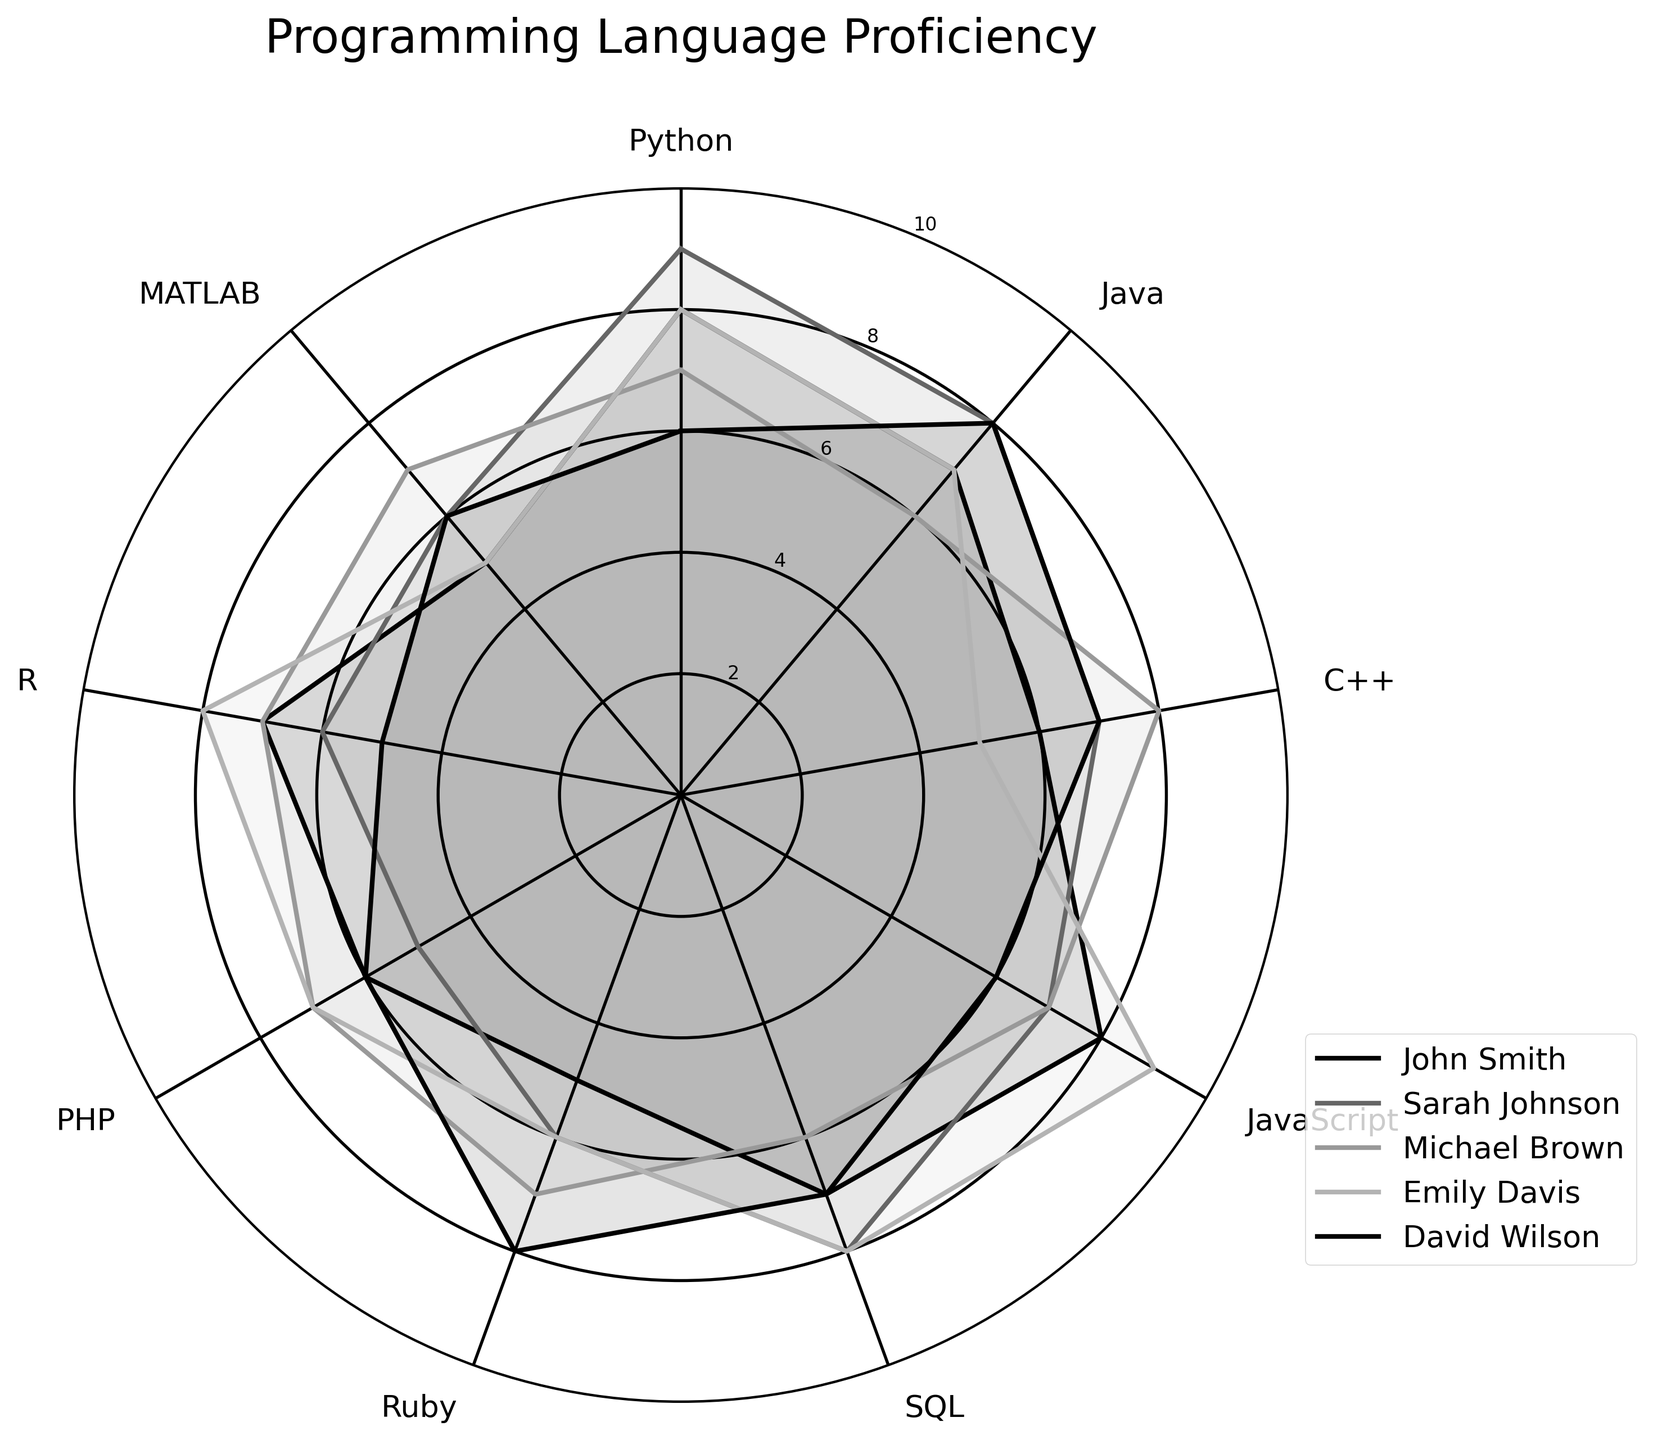How many individuals' proficiencies are depicted in the radar chart? The radar chart represents the programming language proficiencies of five individuals, each associated with different lines and filled areas in the chart.
Answer: 5 Which programming language does Sarah Johnson have the highest proficiency in? By observing Sarah Johnson's plot line in the radar chart, you can see that her peak proficiency value of 9 is in Python.
Answer: Python What is the average proficiency of Michael Brown in Python, Java, and C++ combined? Read Michael Brown's scores: Python (7), Java (6), and C++ (8). The sum is 7 + 6 + 8 = 21. Divide by the number of languages: 21/3 = 7.
Answer: 7 Among all individuals, who has the highest proficiency in Ruby? Observe the radar chart and find the individual whose Ruby proficiency point reaches the highest value. David Wilson has the highest Ruby proficiency with a score of 8.
Answer: David Wilson Compare John Smith's and Emily Davis's proficiencies in JavaScript. Who is more proficient? Check the values in the radar chart where John Smith and Emily Davis intersect with the JavaScript label. John Smith has a proficiency of 8, while Emily Davis has 9. So, Emily Davis is more proficient.
Answer: Emily Davis What is the difference between the highest and lowest proficiency levels of David Wilson? Identify David Wilson's highest (8 in Java) and lowest (5 in R) proficiency scores. Subtracting the lowest from the highest gives 8 - 5 = 3.
Answer: 3 Which individual is relatively balanced in their proficiency across all programming languages? Look for the individual whose plot line forms a relatively even shape without large variations. John Smith’s proficiencies range narrowly from 5 to 8, indicating balanced skills across all languages.
Answer: John Smith What is Emily Davis's proficiency level in SQL compared to R? Check Emily Davis's scores in the radar chart. Her proficiency in SQL is 8 and in R is 8. They are equal.
Answer: Equal Identify the programming language in which each individual's proficiency is at least 7. Assess each individual's proficiency scores through the radar chart for values that are 7 or higher:
- John Smith: Python, Java, JavaScript, SQL, R
- Sarah Johnson: Python, Java, SQL
- Michael Brown: C++, JavaScript, Ruby, PHP, R, MATLAB
- Emily Davis: Python, JavaScript, SQL, R
- David Wilson: Java, C++, Ruby, SQL
Answer: Varies by individual (detailed in explanation) Which programming language has the most consistent proficiency level across all individuals in terms of minimal fluctuation? Look for the smallest range of scores among all the programming languages in the radar chart. Java has proficiency scores ranging from 6 to 8, indicating minimal fluctuation across individuals.
Answer: Java 